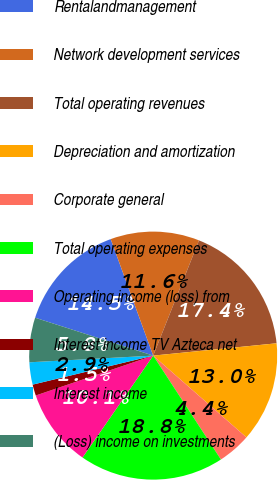Convert chart. <chart><loc_0><loc_0><loc_500><loc_500><pie_chart><fcel>Rentalandmanagement<fcel>Network development services<fcel>Total operating revenues<fcel>Depreciation and amortization<fcel>Corporate general<fcel>Total operating expenses<fcel>Operating income (loss) from<fcel>Interest income TV Azteca net<fcel>Interest income<fcel>(Loss) income on investments<nl><fcel>14.49%<fcel>11.59%<fcel>17.39%<fcel>13.04%<fcel>4.35%<fcel>18.84%<fcel>10.14%<fcel>1.45%<fcel>2.9%<fcel>5.8%<nl></chart> 